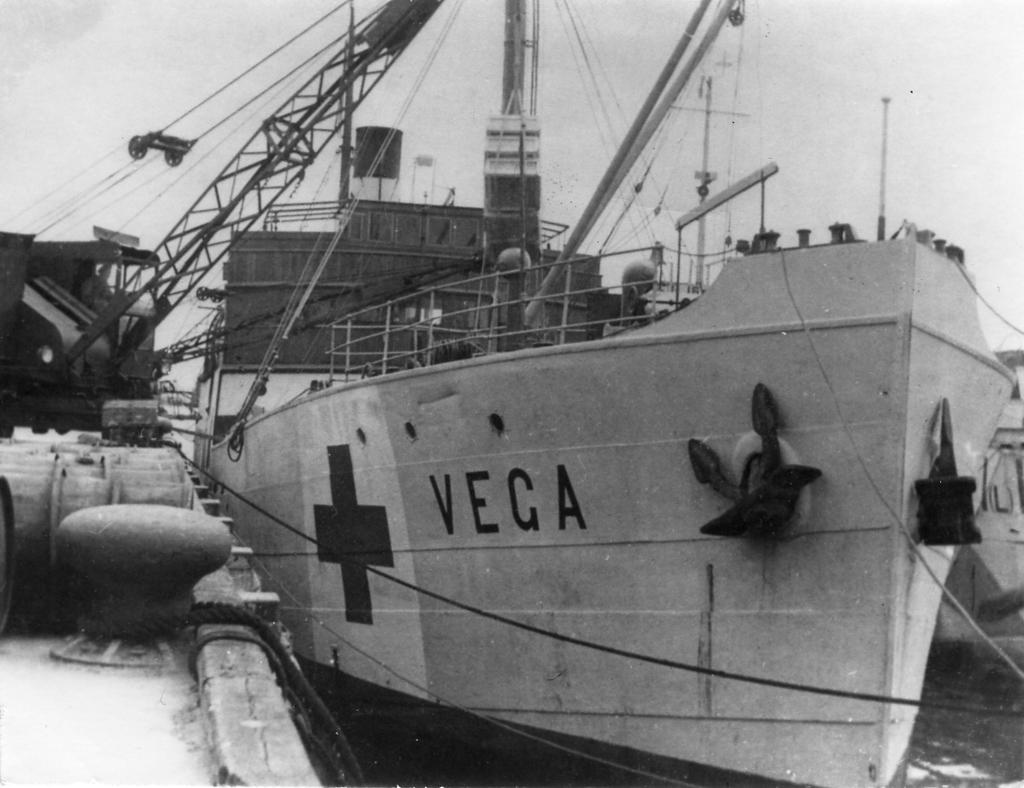What is the main subject of the image? The main subject of the image is a ship. What color scheme is used in the image? The image is in black and white color. What does the son of the ship's captain believe about the shocking event that occurred during their last voyage? There is no information about the ship's captain, their son, or any shocking event in the image. 